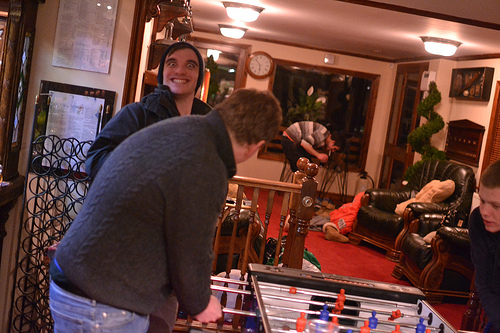<image>
Is there a tree in front of the man? Yes. The tree is positioned in front of the man, appearing closer to the camera viewpoint. 